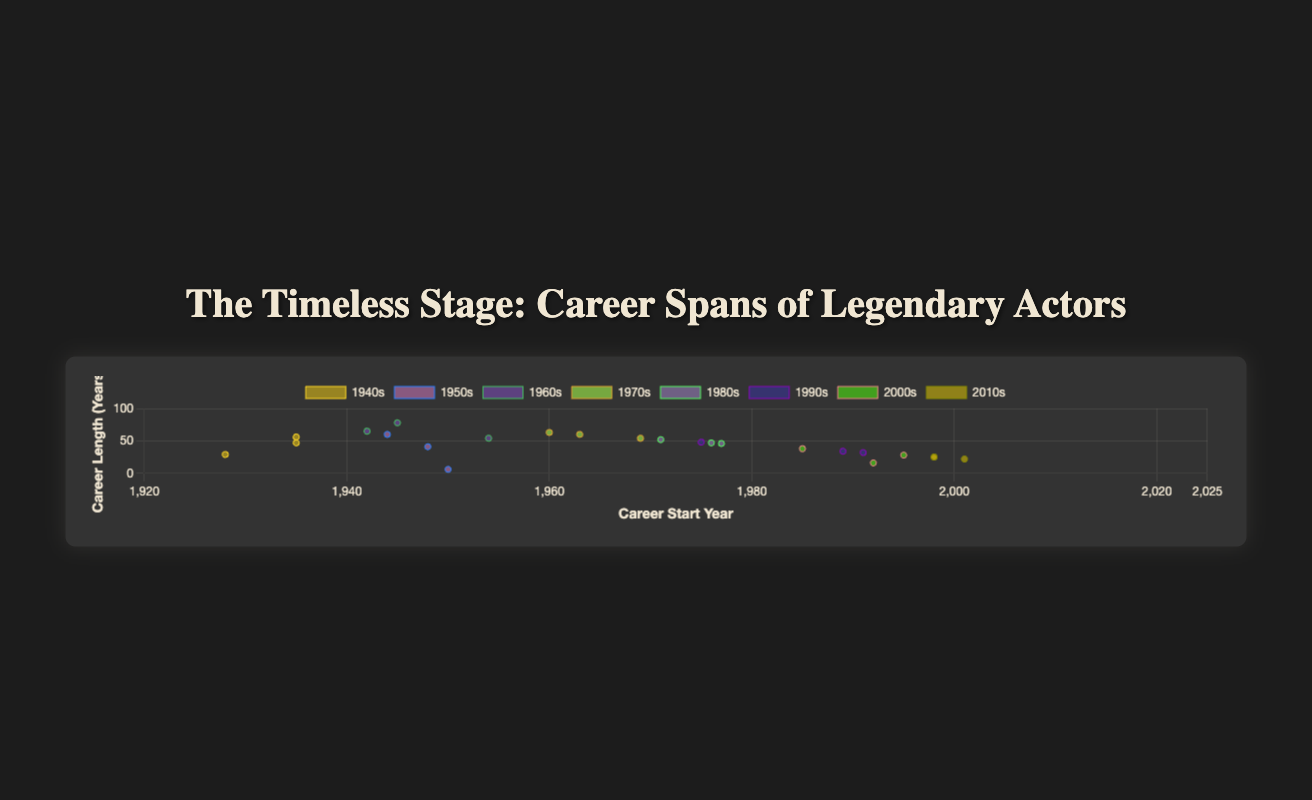What's the title of the figure? The title is displayed at the top of the figure.
Answer: The Timeless Stage: Career Spans of Legendary Actors Which axis represents the career start year? The axis labeled "Career Start Year" represents this information and is the horizontal axis.
Answer: Horizontal axis What is the career length (years) of the actor with the longest career span starting in the 1940s? Lookup the actor in the 1940s dataset whose career started earliest and calculate their career length by subtracting their start year from their end year. Ingrid Bergman’s career lasts from 1935 to 1982, totaling (1982-1935) = 47 years.
Answer: 47 years Which actor's career span started the earliest in the 1980s? Check the actors in the 1980s dataset and identify the actor with the earliest career start year. Meryl Streep's career started in 1971.
Answer: Meryl Streep How does the average career length of actors from the 1970s compare to those from the 2000s? Calculate the average career length for actors from each decade: For the 1970s, the average is (60+53+54)/3 = 55.67 years. For the 2000s, the average is (16+28+38)/3 = 27.33 years. Compare the two values.
Answer: Longer in the 1970s Which actor from the 2010s has the shortest career span? Compare the career lengths of actors from the 2010s (career end year - career start year). Mahershala Ali’s career spans from 2001 to 2023, which is 22 years.
Answer: Mahershala Ali What is the total number of actors represented in the figure? Count all the actors listed across all decades. There are three actors per decade, and there are eight decades (3x8).
Answer: 24 actors 